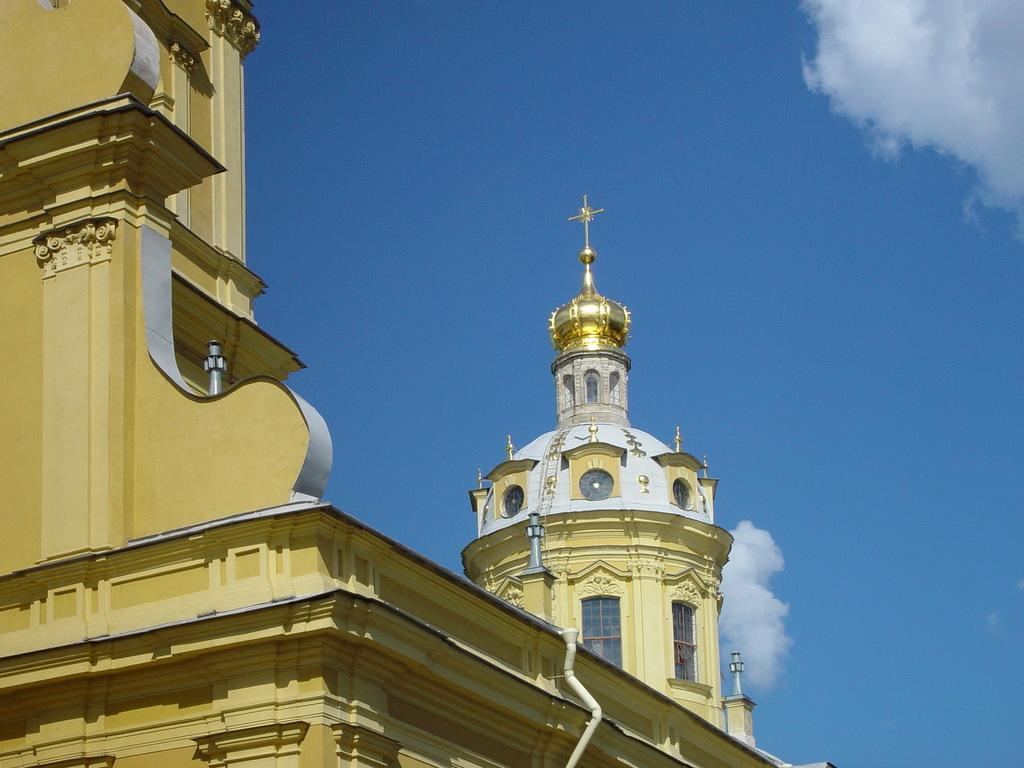What type of structure is in the image? There is a building in the image. What feature can be seen on the building? There is a cross on the building. What can be seen in the sky in the image? The sky is visible in the image, and it looks cloudy. Are there any openings in the building? Yes, the building has windows. Can you describe the crook's property in the image? There is no crook or property mentioned in the image; it features a building with a cross and a cloudy sky. What type of face can be seen on the building in the image? There is no face present on the building in the image. 